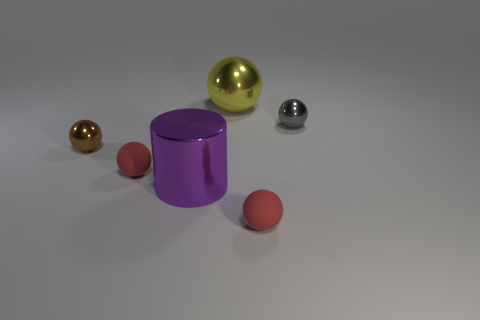Subtract all gray balls. How many balls are left? 4 Subtract all purple spheres. Subtract all cyan blocks. How many spheres are left? 5 Add 4 small yellow rubber things. How many objects exist? 10 Subtract all cylinders. How many objects are left? 5 Subtract all big green rubber cubes. Subtract all rubber objects. How many objects are left? 4 Add 5 large yellow balls. How many large yellow balls are left? 6 Add 1 brown metal things. How many brown metal things exist? 2 Subtract 0 cyan cylinders. How many objects are left? 6 